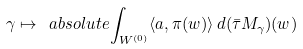<formula> <loc_0><loc_0><loc_500><loc_500>\gamma \mapsto \ a b s o l u t e { \int _ { W ^ { ( 0 ) } } \langle a , \pi ( w ) \rangle \, d ( \bar { \tau } M _ { \gamma } ) ( w ) }</formula> 